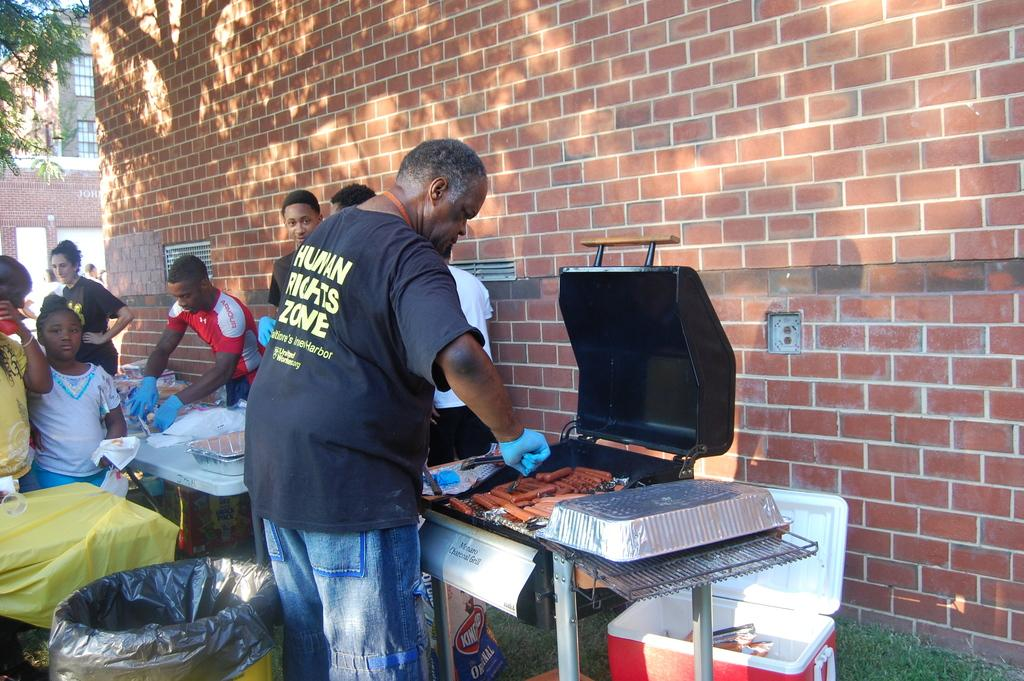<image>
Create a compact narrative representing the image presented. A man wearing a shirt about human rights is cooking hotdog on a grill 